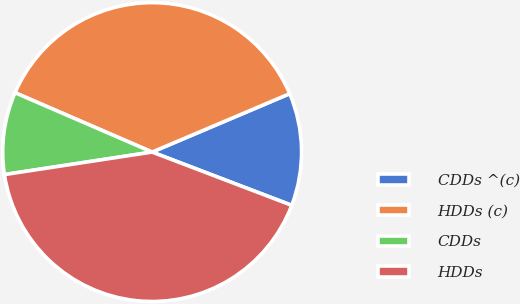<chart> <loc_0><loc_0><loc_500><loc_500><pie_chart><fcel>CDDs ^(c)<fcel>HDDs (c)<fcel>CDDs<fcel>HDDs<nl><fcel>12.19%<fcel>37.11%<fcel>8.91%<fcel>41.79%<nl></chart> 